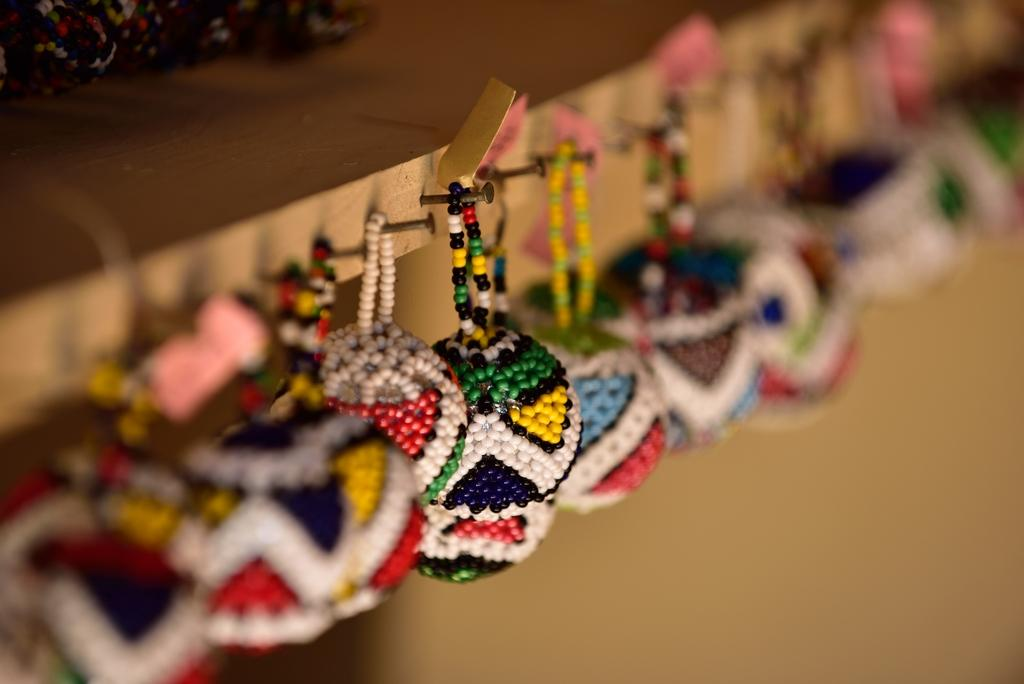What objects are present in the image? There are bead balls in the image. How are the bead balls suspended? The bead balls are hanging from nails. What material is the surface from which the nails are protruding? The nails are on wood. What type of glass is used to make the bead balls in the image? There is no glass present in the image, as the bead balls are made of beads and not glass. 